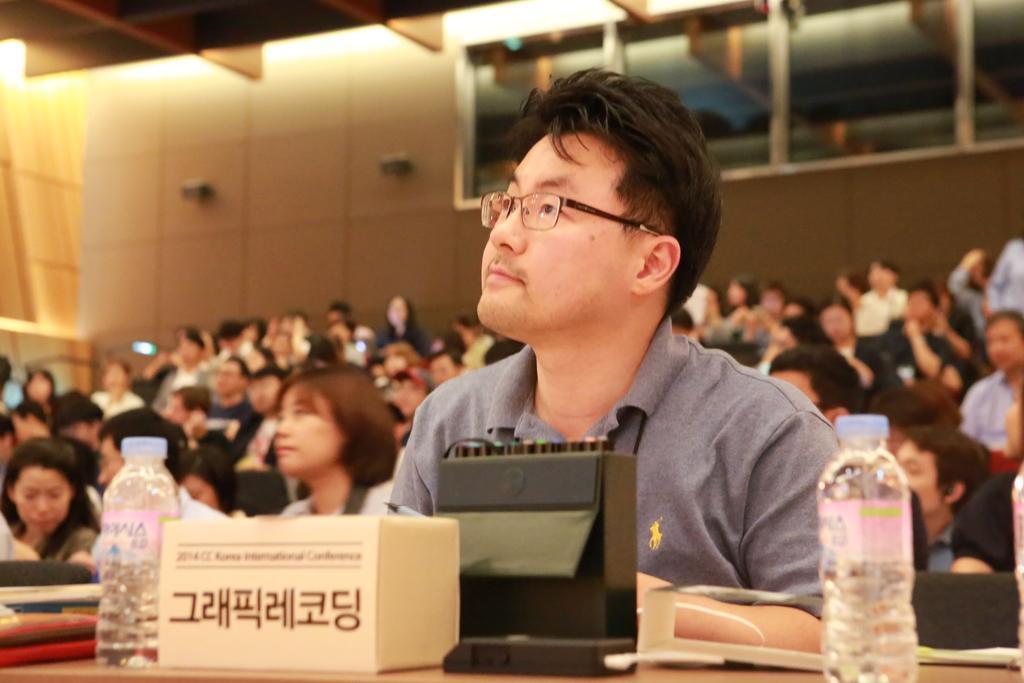In one or two sentences, can you explain what this image depicts? In this picture we can see a man who is sitting on the chair. He has spectacles. And this is table. On the table there are bottles. On the background we can see some persons sitting on the chairs. This is wall and there is a light. 